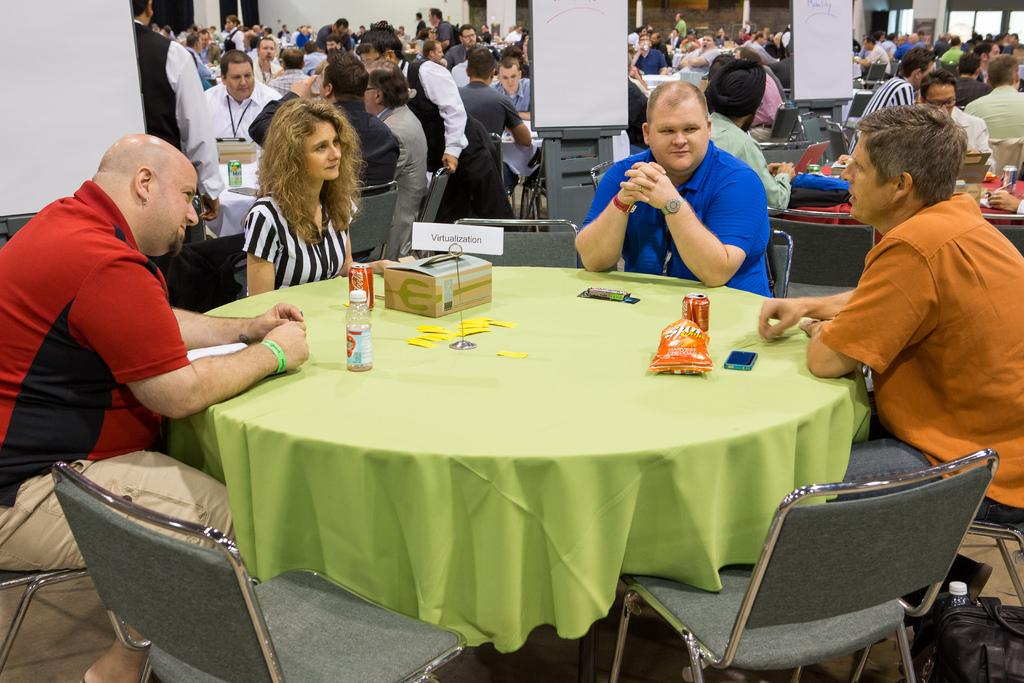How many people are in the image? There is a group of people in the image. What are the people doing in the image? The people are sitting on chairs. How are the chairs arranged in the image? The chairs are arranged around a table. What can be seen on the table in the image? There is a bottle on the table. What type of haircut is the person in the image getting? There is no haircut being performed in the image; the people are sitting on chairs around a table. What kind of event is taking place in the image? The image does not depict a specific event; it simply shows a group of people sitting around a table. 